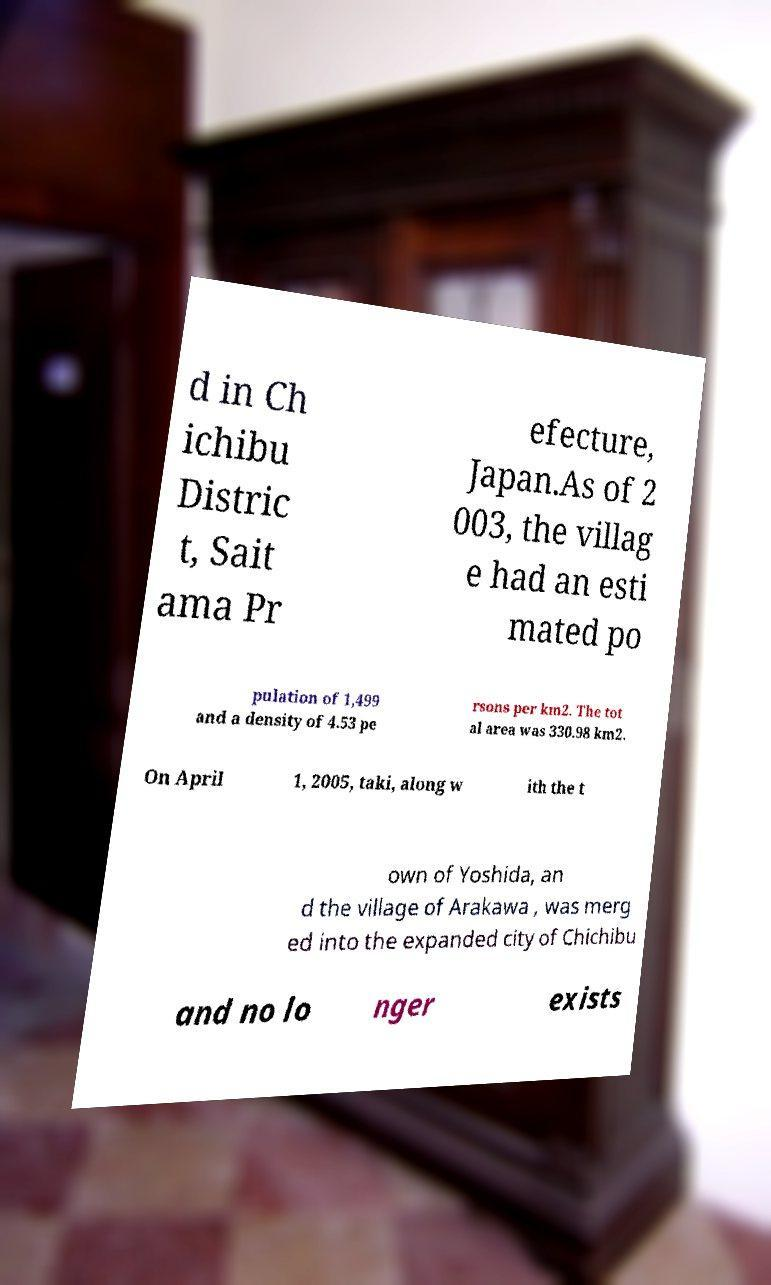Could you assist in decoding the text presented in this image and type it out clearly? d in Ch ichibu Distric t, Sait ama Pr efecture, Japan.As of 2 003, the villag e had an esti mated po pulation of 1,499 and a density of 4.53 pe rsons per km2. The tot al area was 330.98 km2. On April 1, 2005, taki, along w ith the t own of Yoshida, an d the village of Arakawa , was merg ed into the expanded city of Chichibu and no lo nger exists 